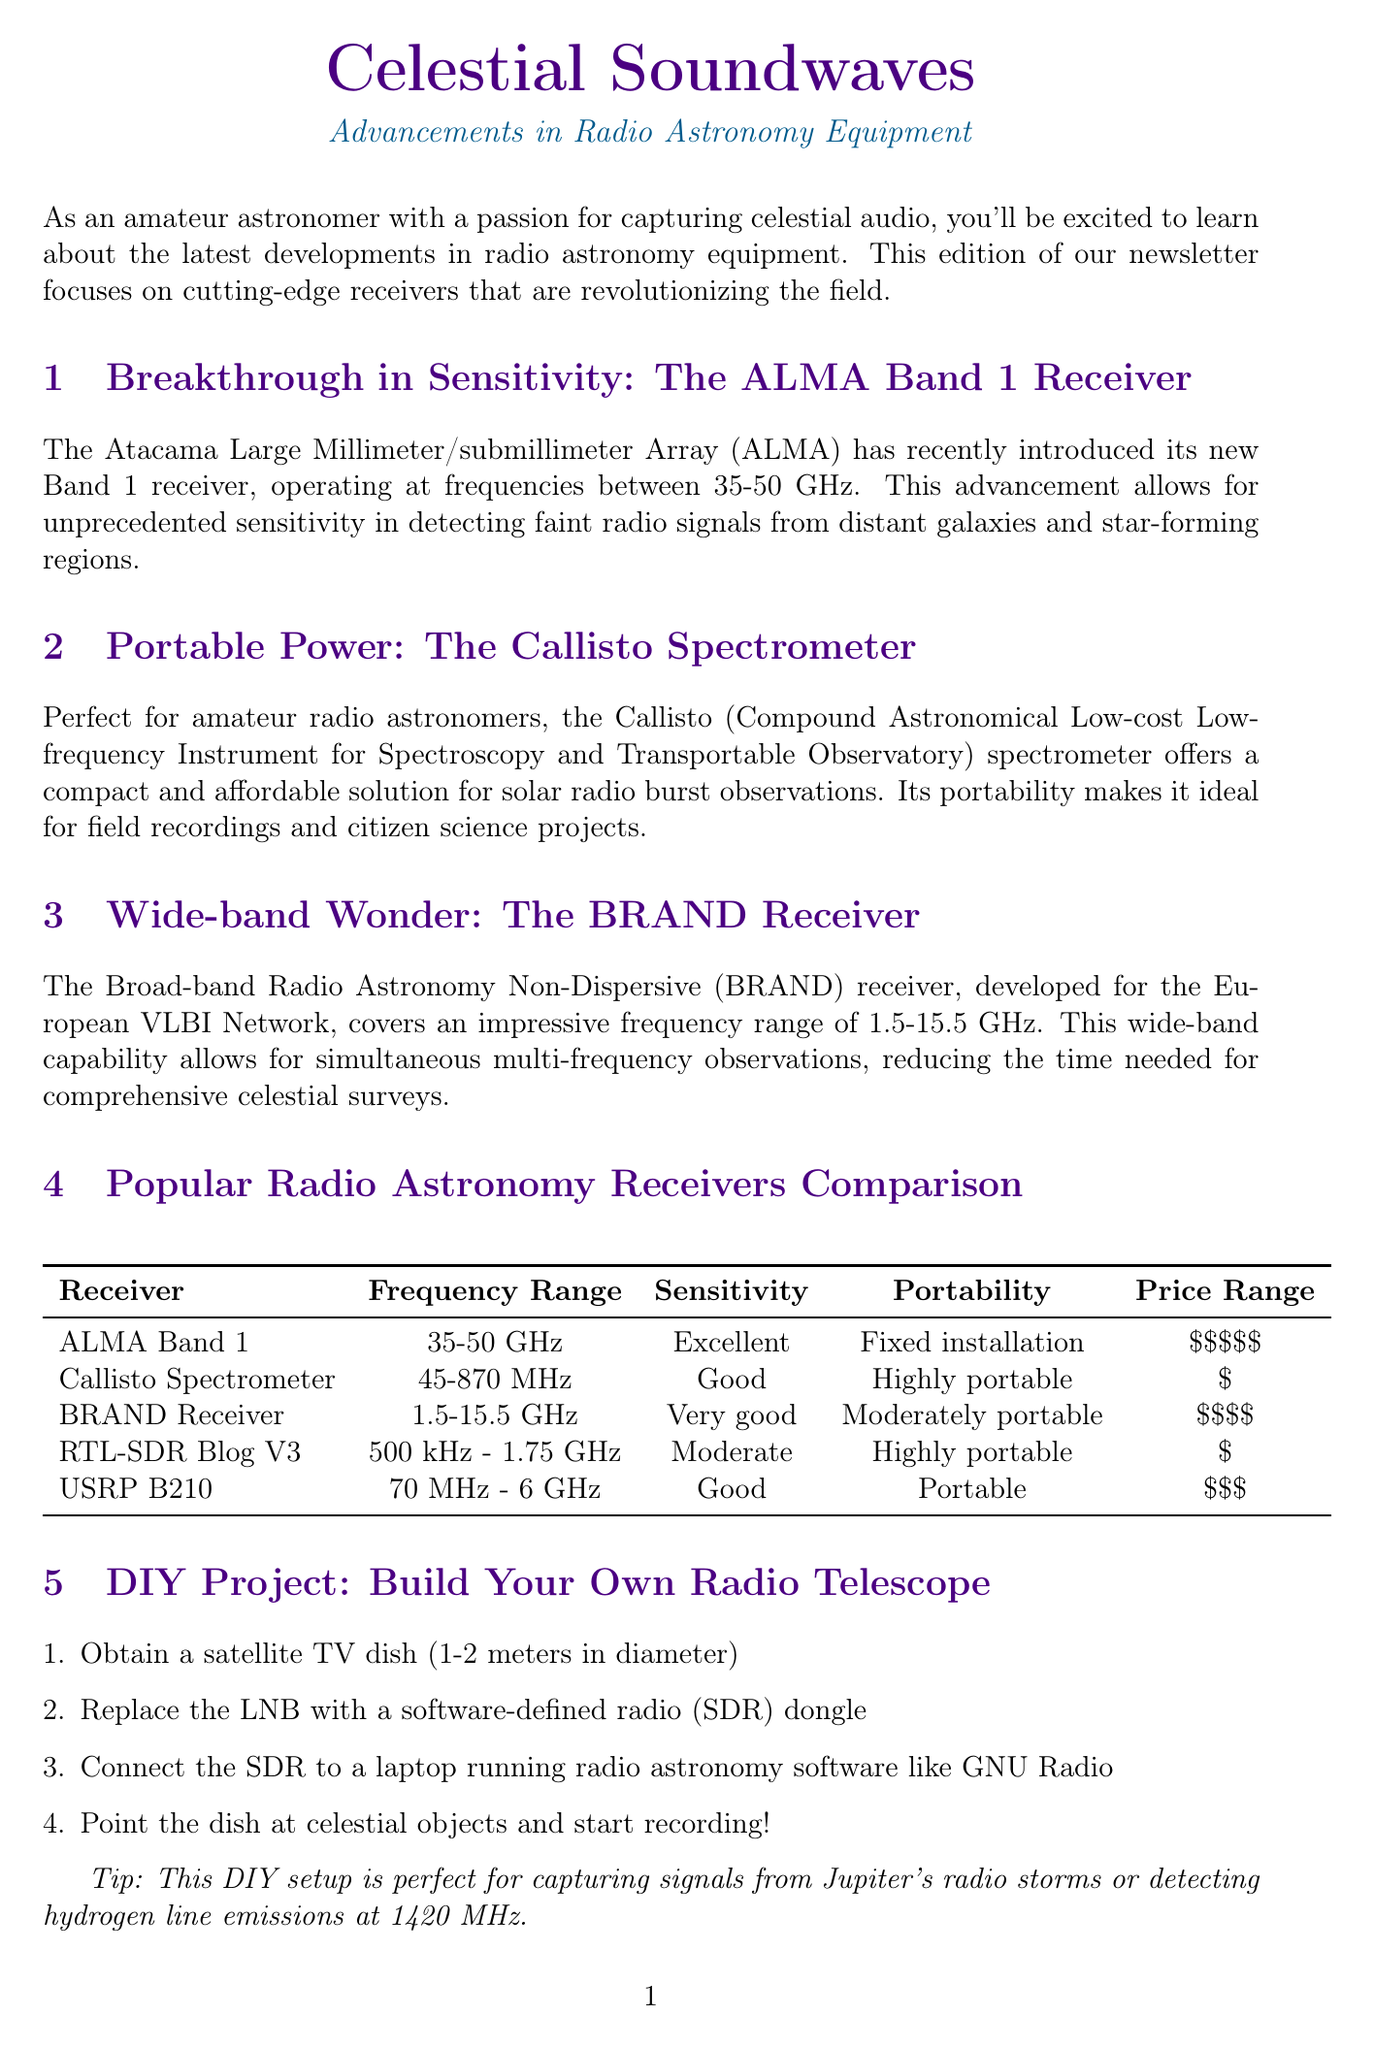What is the title of the newsletter? The title of the newsletter is prominently displayed at the top of the document.
Answer: Celestial Soundwaves What frequency range does the ALMA Band 1 Receiver operate at? The ALMA Band 1 Receiver's operating frequency range is mentioned in its section.
Answer: 35-50 GHz What is the sensitivity rating of the Callisto Spectrometer? The sensitivity rating of each receiver is listed in the comparison chart.
Answer: Good Which receiver is highly portable and has a price range of one dollar? The comparison chart includes details about portability and price range.
Answer: Callisto Spectrometer How many steps are there to build your own radio telescope? The number of steps is indicated in the DIY project section of the document.
Answer: Four What is the date of the International LOFAR User Conference? The date is stated in the upcoming events section.
Answer: September 5-8, 2023 Which receiver covers the frequency range of 1.5-15.5 GHz? This information can be found in the comparison chart under frequency range.
Answer: BRAND Receiver What is a tip provided for the DIY project? The document includes a helpful tip related to the DIY project specifics.
Answer: This DIY setup is perfect for capturing signals from Jupiter's radio storms or detecting hydrogen line emissions at 1420 MHz 